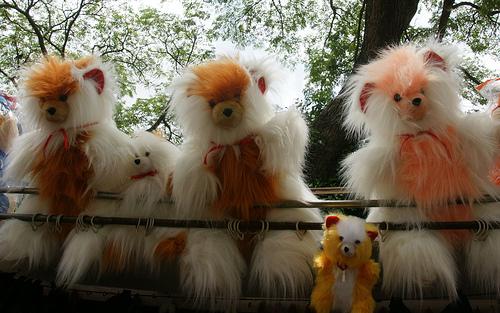Are this dolls stuffed?
Short answer required. Yes. What kind of animals are these stuffed animals emulating?
Keep it brief. Bears. Are all of these stuffed?
Answer briefly. Yes. 